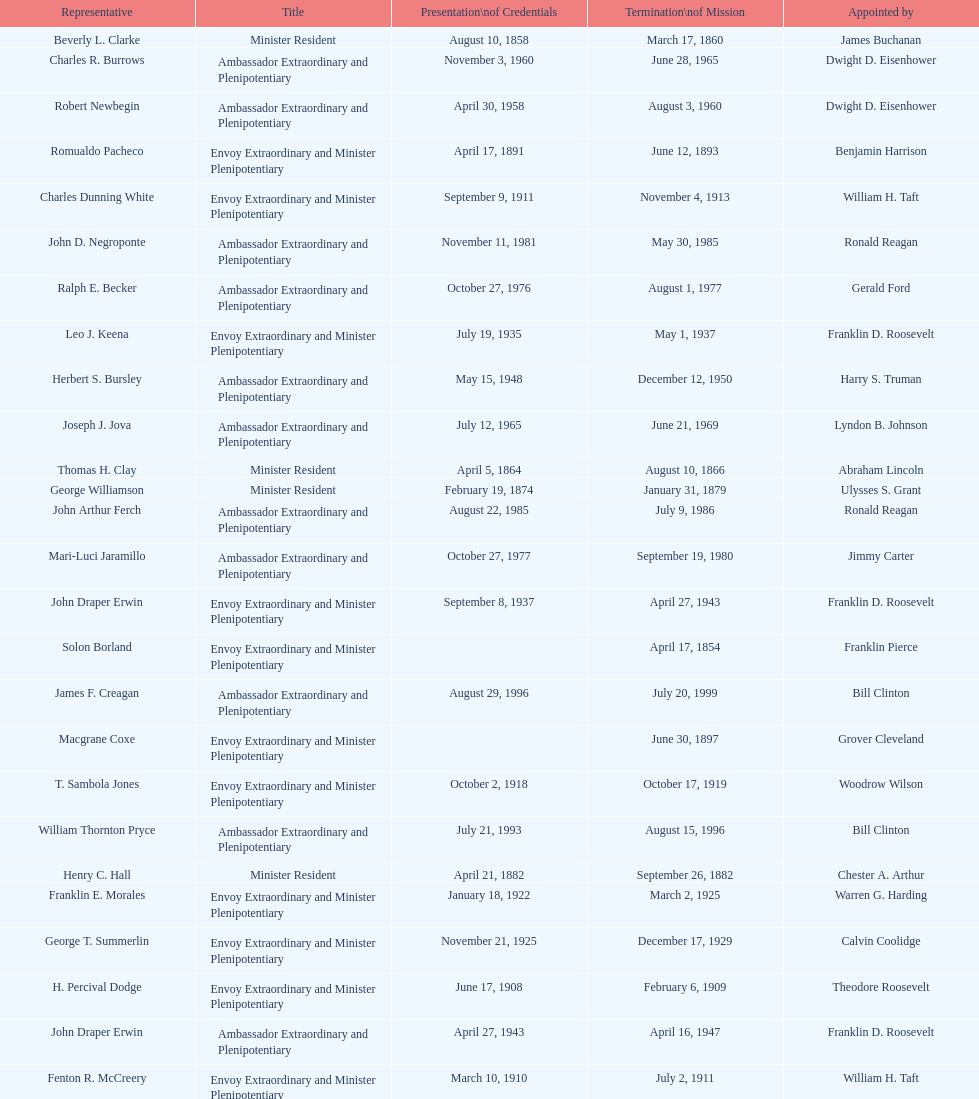What was the length, in years, of leslie combs' term? 4 years. 